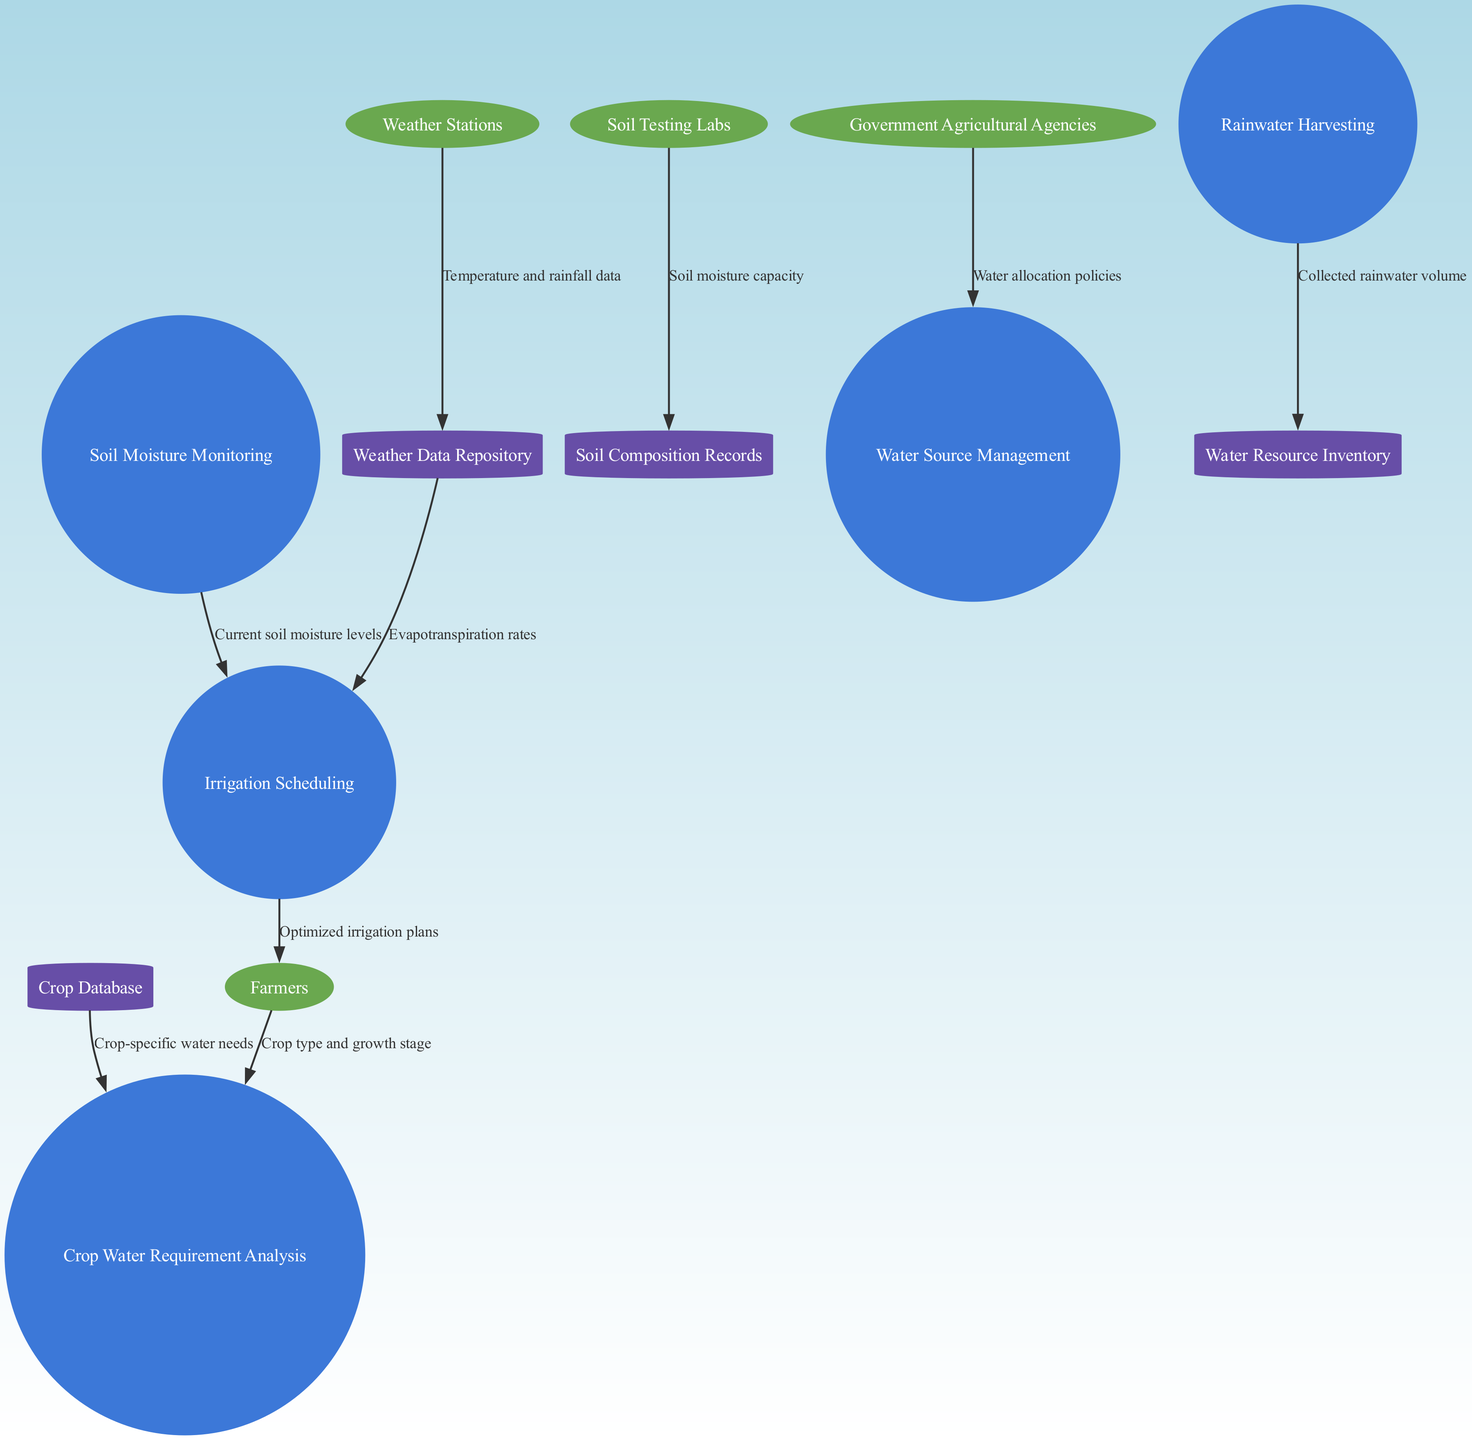What is the first process in the diagram? The first process is identified by reviewing the processes listed in the diagram. In this case, the first one mentioned is "Crop Water Requirement Analysis".
Answer: Crop Water Requirement Analysis How many external entities are present in the diagram? By counting the number of unique external entities provided, we find that there are four: Farmers, Weather Stations, Soil Testing Labs, and Government Agricultural Agencies.
Answer: 4 Which data flow comes from the Weather Stations? To answer, we look for data flows originating from the Weather Stations. The relevant flow is "Temperature and rainfall data" directed to the Weather Data Repository.
Answer: Temperature and rainfall data What data does "Irrigation Scheduling" receive? Analyzing the diagram, we see that "Irrigation Scheduling" receives data from two sources: the Weather Data Repository (Evapotranspiration rates) and Soil Moisture Monitoring (Current soil moisture levels). Comparing both data sources helps identify what inputs it receives.
Answer: Evapotranspiration rates, Current soil moisture levels What is the output of the "Irrigation Scheduling" process? This can be found by checking what data is sent out from the "Irrigation Scheduling" process. The output is "Optimized irrigation plans" sent to the Farmers.
Answer: Optimized irrigation plans Which data storage holds soil moisture information? For this, we check the data stores listed in the diagram to find which one relates to soil moisture. The data store "Soil Composition Records" refers to soil moisture capacity, which includes information about soil moisture.
Answer: Soil Composition Records Describe the connection between the Government Agricultural Agencies and Water Source Management. The diagram shows that Government Agricultural Agencies supply "Water allocation policies" to the Water Source Management process. This relationship indicates a flow of information regarding policies regarding water usage.
Answer: Water allocation policies What type of data is associated with the Rainwater Harvesting process? By reviewing the data flows in the diagram, we locate the Rainwater Harvesting process and see that it contributes "Collected rainwater volume" to the Water Resource Inventory.
Answer: Collected rainwater volume 